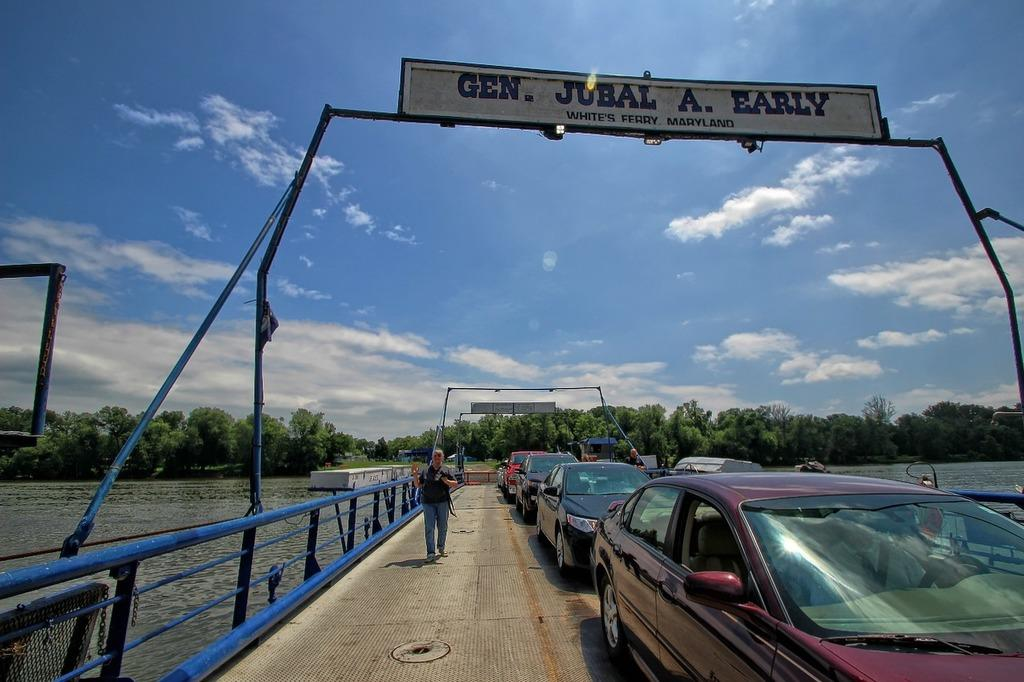<image>
Give a short and clear explanation of the subsequent image. A line of cars are congested in traffic in White's Ferry, Maryland. 